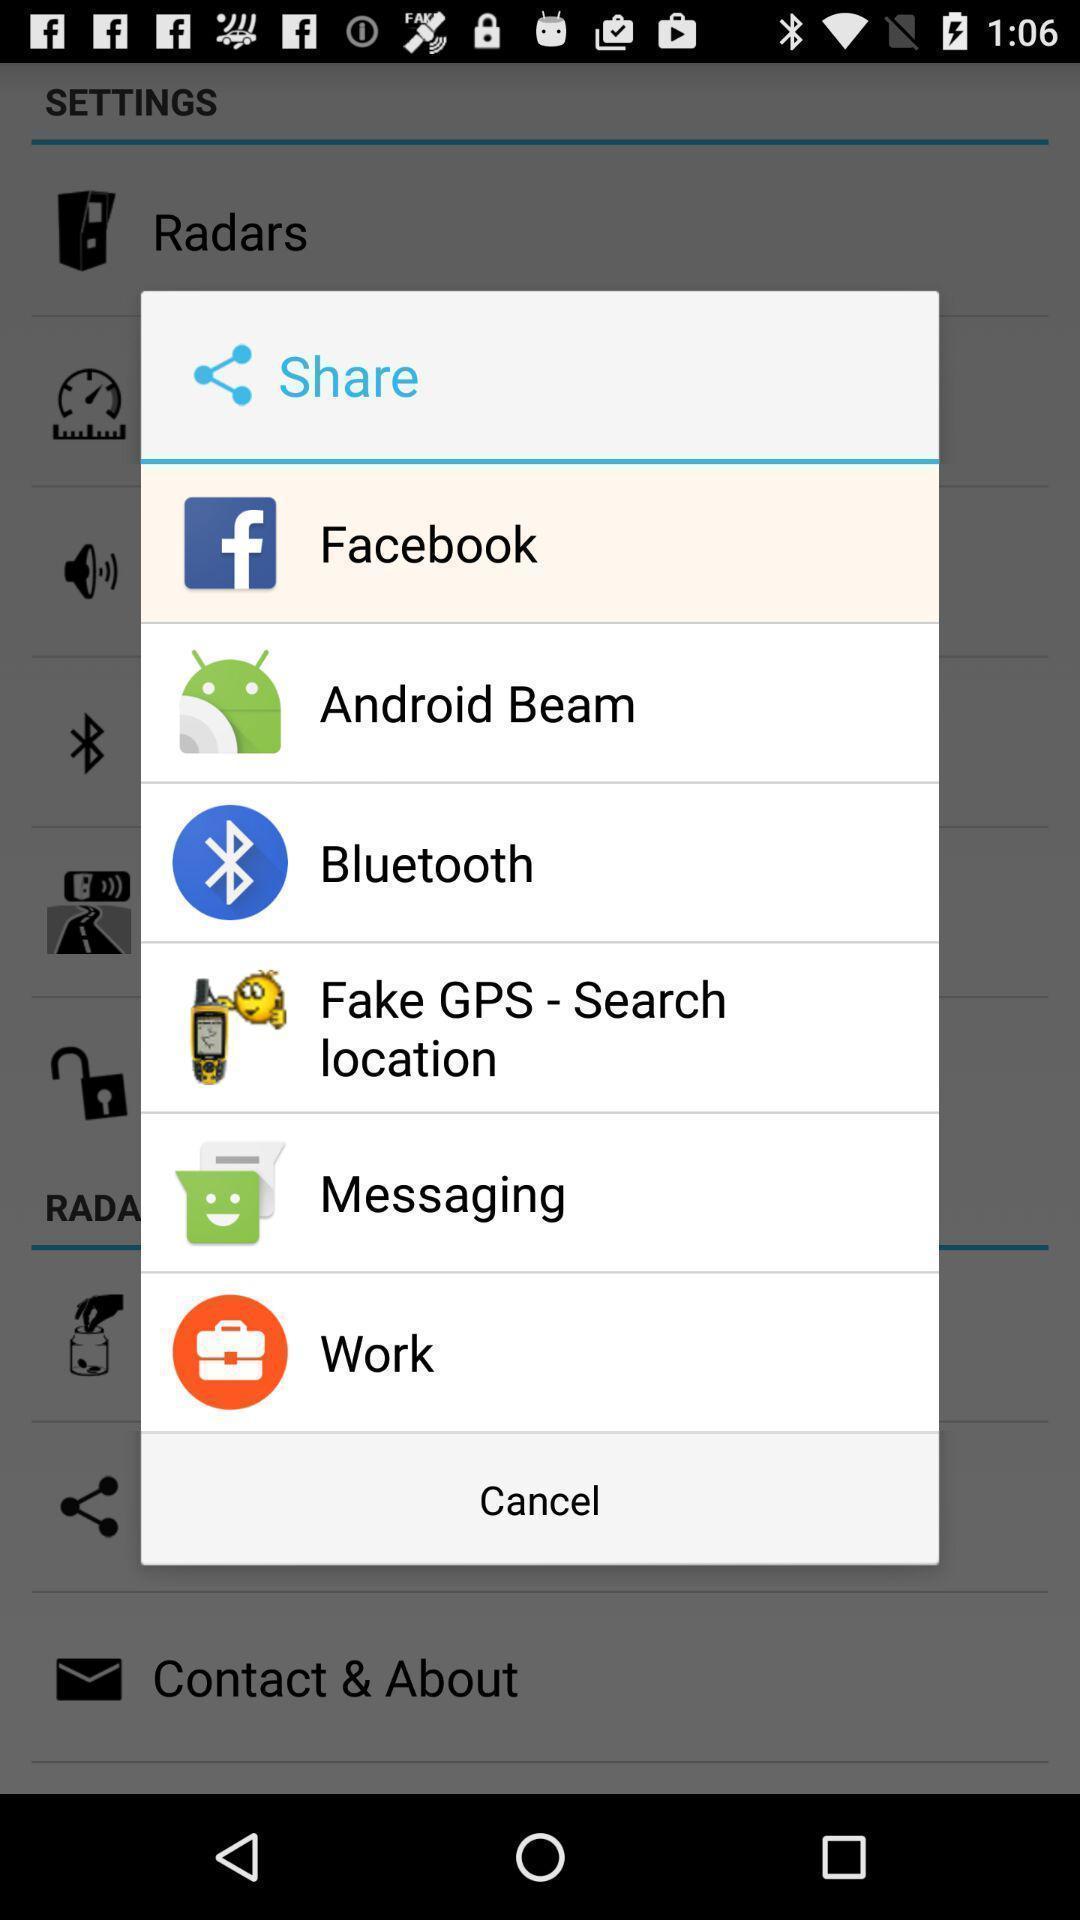Describe the key features of this screenshot. Popup of different kinds of applications to share the info. 